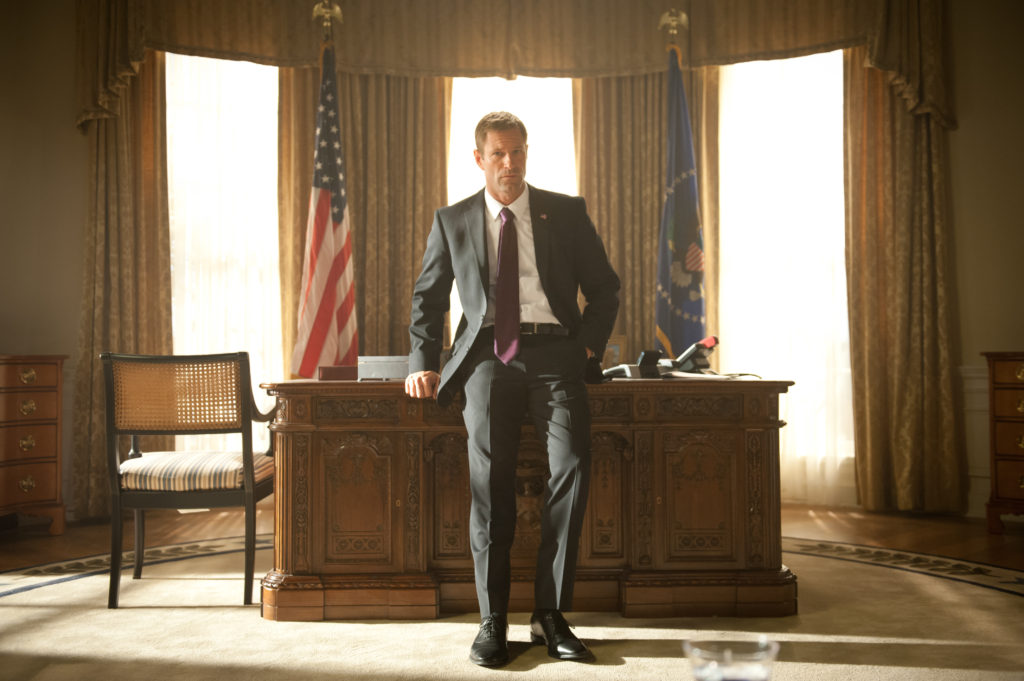Describe the emotions and atmosphere conveyed in this scene. This scene conveys a solemn and intense atmosphere, as evidenced by Aaron Eckhart's serious expression and strong posture. The presence of the American flag and the blue flag with the golden eagle, combined with the meticulous design of the wooden desk and formal décor, enhances the gravity of the setting. The lighting is soft yet purposeful, highlighting the character's contemplative state and emphasizing a sense of responsibility and authority. What might be going through President Asher's mind at this moment? President Asher appears to be deep in thought, likely contemplating a significant decision or reflecting on recent events that have considerable implications. His serious expression and distant gaze suggest he is weighed down by the heavy responsibilities of his role, perhaps grappling with matters of national security or a personal conflict that intertwines with his duty as President. If you had to place a futuristic element in this scene, what would it be? Imagine a large holographic display emerging from the desk, showing real-time data on nationwide security threats and updates. The room could also be equipped with advanced AI assistants providing insights and suggesting possible courses of action based on the data. The historical setting mixed with futuristic technology would create a stark contrast, blending tradition with innovation. Create a scenario where President Asher is dealing with a critical threat. As President Asher leans against the desk, a red alert flashes on the newly installed holographic display, revealing a cyber-attack on the nation's power grid. He quickly gathers his team of security advisors and top intelligence officers around the desk. The room buzzes with tension as the team devises an immediate action plan to counter the attack and secure vital infrastructures, all while ensuring public safety and maintaining order. Asher remains calm and focused, directing his team with precision, showcasing his leadership in the face of crisis. 